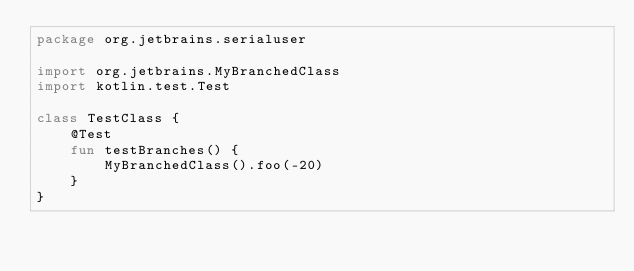<code> <loc_0><loc_0><loc_500><loc_500><_Kotlin_>package org.jetbrains.serialuser

import org.jetbrains.MyBranchedClass
import kotlin.test.Test

class TestClass {
    @Test
    fun testBranches() {
        MyBranchedClass().foo(-20)
    }
}
</code> 